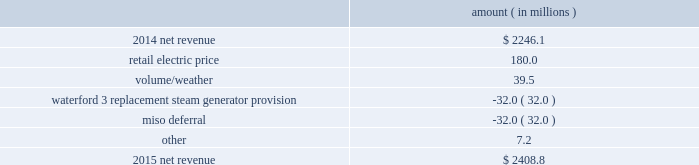Entergy louisiana , llc and subsidiaries management 2019s financial discussion and analysis in industrial usage is primarily due to increased demand from new customers and expansion projects , primarily in the chemicals industry .
The louisiana act 55 financing savings obligation variance results from a regulatory charge for tax savings to be shared with customers per an agreement approved by the lpsc .
The tax savings resulted from the 2010-2011 irs audit settlement on the treatment of the louisiana act 55 financing of storm costs for hurricane gustav and hurricane ike .
See note 3 to the financial statements for additional discussion of the settlement and benefit sharing .
Included in other is a provision of $ 23 million recorded in 2016 related to the settlement of the waterford 3 replacement steam generator prudence review proceeding , offset by a provision of $ 32 million recorded in 2015 related to the uncertainty at that time associated with the resolution of the waterford 3 replacement steam generator prudence review proceeding .
See note 2 to the financial statements for a discussion of the waterford 3 replacement steam generator prudence review proceeding .
2015 compared to 2014 net revenue consists of operating revenues net of : 1 ) fuel , fuel-related expenses , and gas purchased for resale , 2 ) purchased power expenses , and 3 ) other regulatory charges ( credits ) .
Following is an analysis of the change in net revenue comparing 2015 to 2014 .
Amount ( in millions ) .
The retail electric price variance is primarily due to formula rate plan increases , as approved by the lpsc , effective december 2014 and january 2015 .
Entergy louisiana 2019s formula rate plan increases are discussed in note 2 to the financial statements .
The volume/weather variance is primarily due to an increase of 841 gwh , or 2% ( 2 % ) , in billed electricity usage , as a result of increased industrial usage primarily due to increased demand for existing large refinery customers , new customers , and expansion projects primarily in the chemicals industry , partially offset by a decrease in demand in the chemicals industry as a result of a seasonal outage for an existing customer .
The waterford 3 replacement steam generator provision is due to a regulatory charge of approximately $ 32 million recorded in 2015 related to the uncertainty associated with the resolution of the waterford 3 replacement steam generator project .
See note 2 to the financial statements for a discussion of the waterford 3 replacement steam generator prudence review proceeding .
The miso deferral variance is due to the deferral in 2014 of non-fuel miso-related charges , as approved by the lpsc .
The deferral of non-fuel miso-related charges is partially offset in other operation and maintenance expenses .
See note 2 to the financial statements for further discussion of the recovery of non-fuel miso-related charges. .
What is the growth rate in net revenue in 2015 for entergy louisiana? 
Computations: ((2408.8 - 2246.1) / 2246.1)
Answer: 0.07244. Entergy louisiana , llc and subsidiaries management 2019s financial discussion and analysis in industrial usage is primarily due to increased demand from new customers and expansion projects , primarily in the chemicals industry .
The louisiana act 55 financing savings obligation variance results from a regulatory charge for tax savings to be shared with customers per an agreement approved by the lpsc .
The tax savings resulted from the 2010-2011 irs audit settlement on the treatment of the louisiana act 55 financing of storm costs for hurricane gustav and hurricane ike .
See note 3 to the financial statements for additional discussion of the settlement and benefit sharing .
Included in other is a provision of $ 23 million recorded in 2016 related to the settlement of the waterford 3 replacement steam generator prudence review proceeding , offset by a provision of $ 32 million recorded in 2015 related to the uncertainty at that time associated with the resolution of the waterford 3 replacement steam generator prudence review proceeding .
See note 2 to the financial statements for a discussion of the waterford 3 replacement steam generator prudence review proceeding .
2015 compared to 2014 net revenue consists of operating revenues net of : 1 ) fuel , fuel-related expenses , and gas purchased for resale , 2 ) purchased power expenses , and 3 ) other regulatory charges ( credits ) .
Following is an analysis of the change in net revenue comparing 2015 to 2014 .
Amount ( in millions ) .
The retail electric price variance is primarily due to formula rate plan increases , as approved by the lpsc , effective december 2014 and january 2015 .
Entergy louisiana 2019s formula rate plan increases are discussed in note 2 to the financial statements .
The volume/weather variance is primarily due to an increase of 841 gwh , or 2% ( 2 % ) , in billed electricity usage , as a result of increased industrial usage primarily due to increased demand for existing large refinery customers , new customers , and expansion projects primarily in the chemicals industry , partially offset by a decrease in demand in the chemicals industry as a result of a seasonal outage for an existing customer .
The waterford 3 replacement steam generator provision is due to a regulatory charge of approximately $ 32 million recorded in 2015 related to the uncertainty associated with the resolution of the waterford 3 replacement steam generator project .
See note 2 to the financial statements for a discussion of the waterford 3 replacement steam generator prudence review proceeding .
The miso deferral variance is due to the deferral in 2014 of non-fuel miso-related charges , as approved by the lpsc .
The deferral of non-fuel miso-related charges is partially offset in other operation and maintenance expenses .
See note 2 to the financial statements for further discussion of the recovery of non-fuel miso-related charges. .
The retail electric price adjustment accounted for what percentage of the 2015 total net revenue? 
Computations: (180.0 / 2408.8)
Answer: 0.07473. Entergy louisiana , llc and subsidiaries management 2019s financial discussion and analysis in industrial usage is primarily due to increased demand from new customers and expansion projects , primarily in the chemicals industry .
The louisiana act 55 financing savings obligation variance results from a regulatory charge for tax savings to be shared with customers per an agreement approved by the lpsc .
The tax savings resulted from the 2010-2011 irs audit settlement on the treatment of the louisiana act 55 financing of storm costs for hurricane gustav and hurricane ike .
See note 3 to the financial statements for additional discussion of the settlement and benefit sharing .
Included in other is a provision of $ 23 million recorded in 2016 related to the settlement of the waterford 3 replacement steam generator prudence review proceeding , offset by a provision of $ 32 million recorded in 2015 related to the uncertainty at that time associated with the resolution of the waterford 3 replacement steam generator prudence review proceeding .
See note 2 to the financial statements for a discussion of the waterford 3 replacement steam generator prudence review proceeding .
2015 compared to 2014 net revenue consists of operating revenues net of : 1 ) fuel , fuel-related expenses , and gas purchased for resale , 2 ) purchased power expenses , and 3 ) other regulatory charges ( credits ) .
Following is an analysis of the change in net revenue comparing 2015 to 2014 .
Amount ( in millions ) .
The retail electric price variance is primarily due to formula rate plan increases , as approved by the lpsc , effective december 2014 and january 2015 .
Entergy louisiana 2019s formula rate plan increases are discussed in note 2 to the financial statements .
The volume/weather variance is primarily due to an increase of 841 gwh , or 2% ( 2 % ) , in billed electricity usage , as a result of increased industrial usage primarily due to increased demand for existing large refinery customers , new customers , and expansion projects primarily in the chemicals industry , partially offset by a decrease in demand in the chemicals industry as a result of a seasonal outage for an existing customer .
The waterford 3 replacement steam generator provision is due to a regulatory charge of approximately $ 32 million recorded in 2015 related to the uncertainty associated with the resolution of the waterford 3 replacement steam generator project .
See note 2 to the financial statements for a discussion of the waterford 3 replacement steam generator prudence review proceeding .
The miso deferral variance is due to the deferral in 2014 of non-fuel miso-related charges , as approved by the lpsc .
The deferral of non-fuel miso-related charges is partially offset in other operation and maintenance expenses .
See note 2 to the financial statements for further discussion of the recovery of non-fuel miso-related charges. .
Without the benefit of the retail electric price and volume/weather adjustments , what would the 2015 net revenue be , in millions? 
Computations: (2408.8 - (180.0 + 39.5))
Answer: 2189.3. Entergy louisiana , llc and subsidiaries management 2019s financial discussion and analysis in industrial usage is primarily due to increased demand from new customers and expansion projects , primarily in the chemicals industry .
The louisiana act 55 financing savings obligation variance results from a regulatory charge for tax savings to be shared with customers per an agreement approved by the lpsc .
The tax savings resulted from the 2010-2011 irs audit settlement on the treatment of the louisiana act 55 financing of storm costs for hurricane gustav and hurricane ike .
See note 3 to the financial statements for additional discussion of the settlement and benefit sharing .
Included in other is a provision of $ 23 million recorded in 2016 related to the settlement of the waterford 3 replacement steam generator prudence review proceeding , offset by a provision of $ 32 million recorded in 2015 related to the uncertainty at that time associated with the resolution of the waterford 3 replacement steam generator prudence review proceeding .
See note 2 to the financial statements for a discussion of the waterford 3 replacement steam generator prudence review proceeding .
2015 compared to 2014 net revenue consists of operating revenues net of : 1 ) fuel , fuel-related expenses , and gas purchased for resale , 2 ) purchased power expenses , and 3 ) other regulatory charges ( credits ) .
Following is an analysis of the change in net revenue comparing 2015 to 2014 .
Amount ( in millions ) .
The retail electric price variance is primarily due to formula rate plan increases , as approved by the lpsc , effective december 2014 and january 2015 .
Entergy louisiana 2019s formula rate plan increases are discussed in note 2 to the financial statements .
The volume/weather variance is primarily due to an increase of 841 gwh , or 2% ( 2 % ) , in billed electricity usage , as a result of increased industrial usage primarily due to increased demand for existing large refinery customers , new customers , and expansion projects primarily in the chemicals industry , partially offset by a decrease in demand in the chemicals industry as a result of a seasonal outage for an existing customer .
The waterford 3 replacement steam generator provision is due to a regulatory charge of approximately $ 32 million recorded in 2015 related to the uncertainty associated with the resolution of the waterford 3 replacement steam generator project .
See note 2 to the financial statements for a discussion of the waterford 3 replacement steam generator prudence review proceeding .
The miso deferral variance is due to the deferral in 2014 of non-fuel miso-related charges , as approved by the lpsc .
The deferral of non-fuel miso-related charges is partially offset in other operation and maintenance expenses .
See note 2 to the financial statements for further discussion of the recovery of non-fuel miso-related charges. .
What is the net change in net revenue during 2015 for entergy louisiana? 
Computations: (2408.8 - 2246.1)
Answer: 162.7. 